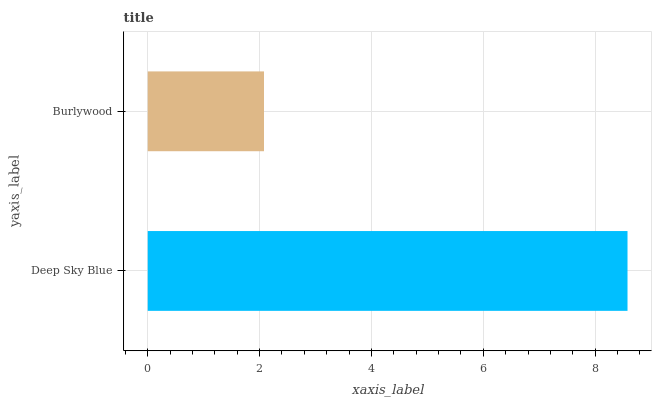Is Burlywood the minimum?
Answer yes or no. Yes. Is Deep Sky Blue the maximum?
Answer yes or no. Yes. Is Burlywood the maximum?
Answer yes or no. No. Is Deep Sky Blue greater than Burlywood?
Answer yes or no. Yes. Is Burlywood less than Deep Sky Blue?
Answer yes or no. Yes. Is Burlywood greater than Deep Sky Blue?
Answer yes or no. No. Is Deep Sky Blue less than Burlywood?
Answer yes or no. No. Is Deep Sky Blue the high median?
Answer yes or no. Yes. Is Burlywood the low median?
Answer yes or no. Yes. Is Burlywood the high median?
Answer yes or no. No. Is Deep Sky Blue the low median?
Answer yes or no. No. 